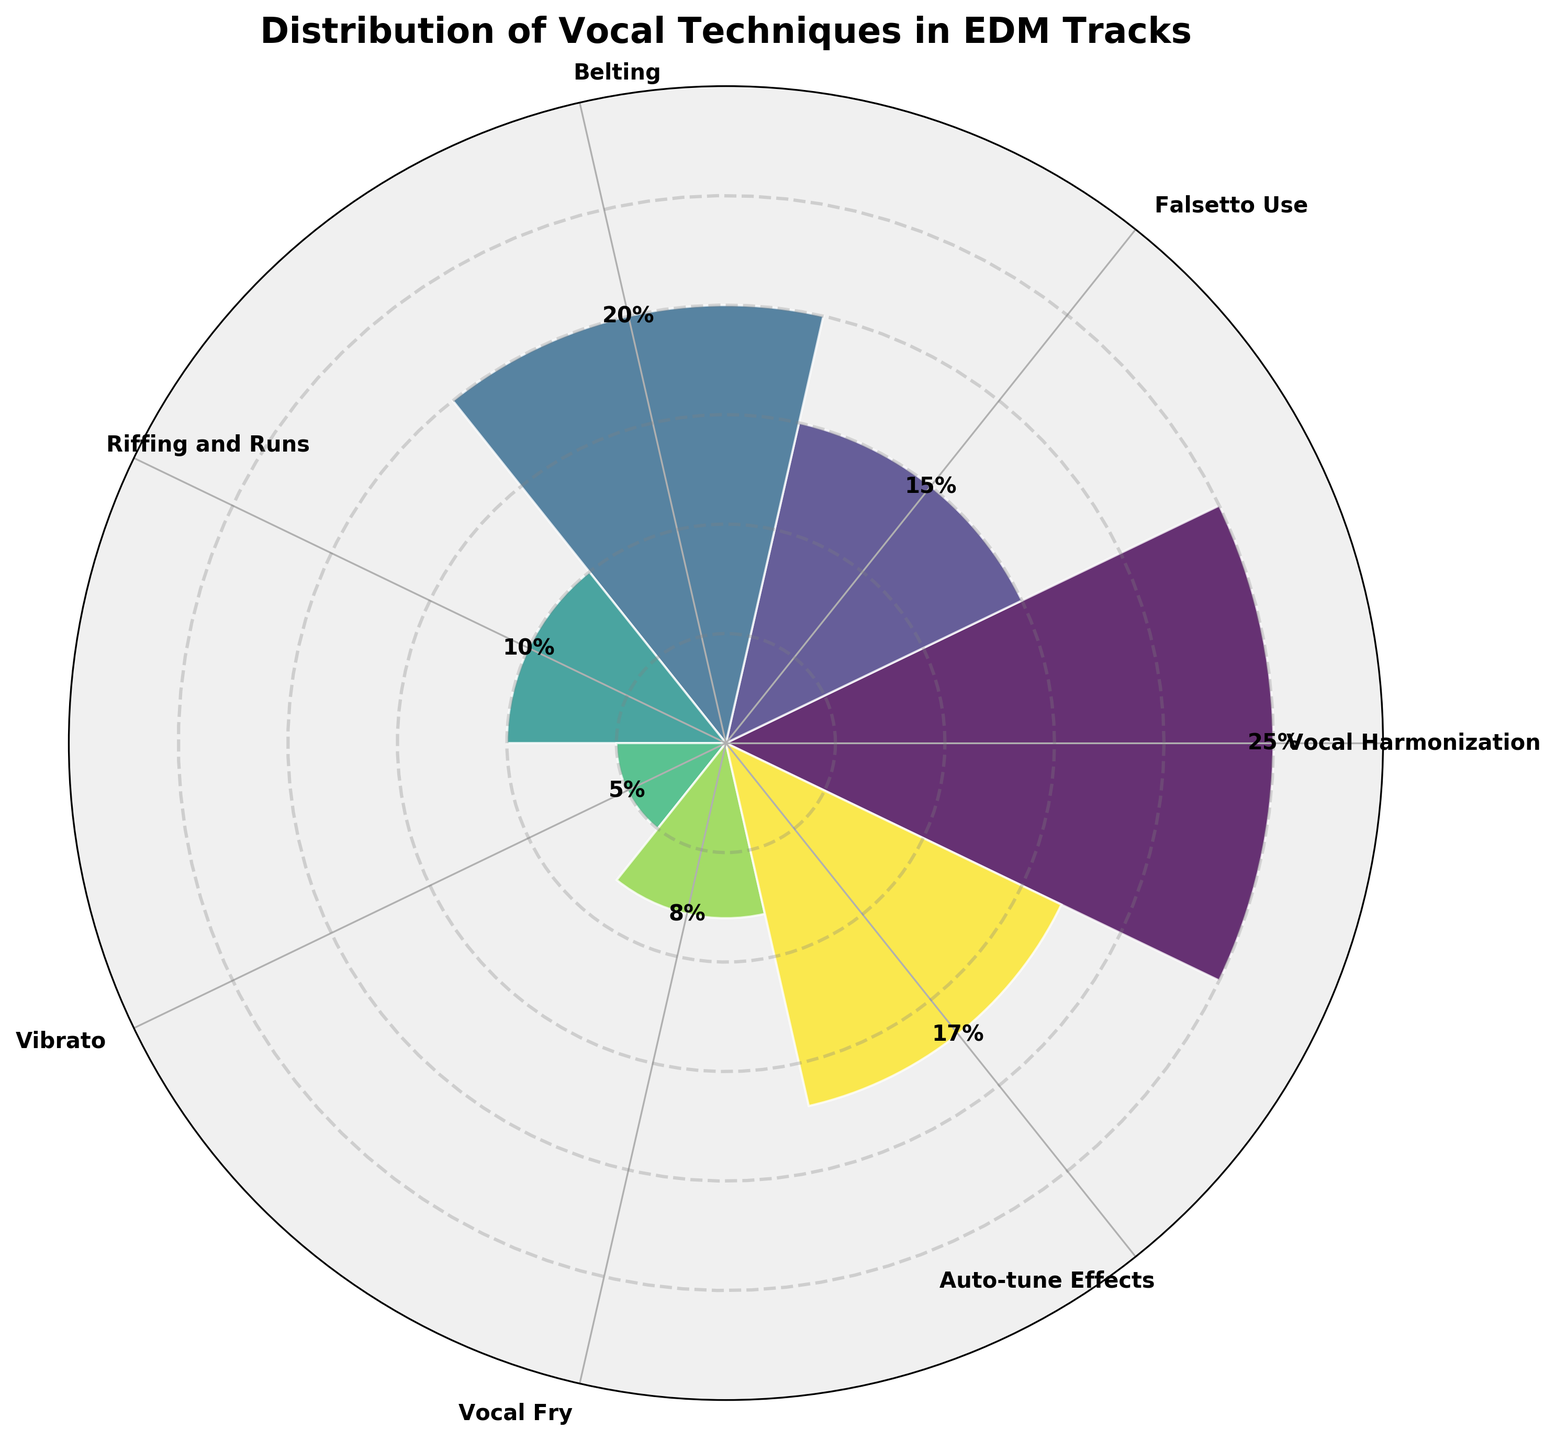What is the title of the chart? The title of the chart is written at the top. It is clearly shown as "Distribution of Vocal Techniques in EDM Tracks."
Answer: Distribution of Vocal Techniques in EDM Tracks Which vocal technique has the highest percentage? By looking at the lengths of the bars, the longest bar represents "Vocal Harmonization." This indicates it has the highest percentage.
Answer: Vocal Harmonization How many categories are represented in the chart? There are multiple sectors in the polar area chart, each representing a different vocal technique. Counting them gives a total of 7 categories.
Answer: 7 What percentage of tracks use belting? The bar for "Belting" is marked with its percentage value. This value is displayed as 20%.
Answer: 20% Which two categories have the smallest percentages? By observing the shortest bars, the categories with the smallest percentages appear to be "Vibrato" and "Vocal Fry," with "Vibrato" being the smallest at 5% and "Vocal Fry" at 8%.
Answer: Vibrato and Vocal Fry What is the combined percentage for "Auto-tune Effects" and "Falsetto Use"? The percentages for "Auto-tune Effects" and "Falsetto Use" are 17% and 15%, respectively. Adding them together, 17% + 15% = 32%.
Answer: 32% How does the percentage of "Riffing and Runs" compare to "Auto-tune Effects"? Comparing the lengths of the bars, "Riffing and Runs" is 10% and "Auto-tune Effects" is 17%. Thus, "Riffing and Runs" is less than "Auto-tune Effects."
Answer: Riffing and Runs is less than Auto-tune Effects What difference in percentage is there between "Vocal Harmonization" and "Belting"? "Vocal Harmonization" has 25% and "Belting" has 20%. Subtracting these, 25% - 20% gives a difference of 5%.
Answer: 5% What is the average percentage of all vocal techniques used? Adding all the percentages: 25% + 15% + 20% + 10% + 5% + 8% + 17% = 100%. The average is 100% divided by the number of categories, 7. Thus, the average is 100% / 7 ≈ 14.29%.
Answer: 14.29% Is any category above 20%? Only one bar exceeds the 20% mark, which is "Vocal Harmonization" at 25%. All others are at or below 20%.
Answer: Yes, Vocal Harmonization 